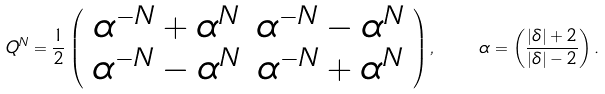<formula> <loc_0><loc_0><loc_500><loc_500>Q ^ { N } = \frac { 1 } { 2 } \left ( \begin{array} { c c } \alpha ^ { - N } + \alpha ^ { N } & \alpha ^ { - N } - \alpha ^ { N } \\ \alpha ^ { - N } - \alpha ^ { N } & \alpha ^ { - N } + \alpha ^ { N } \end{array} \right ) , \quad \alpha = \left ( \frac { | \delta | + 2 } { | \delta | - 2 } \right ) .</formula> 